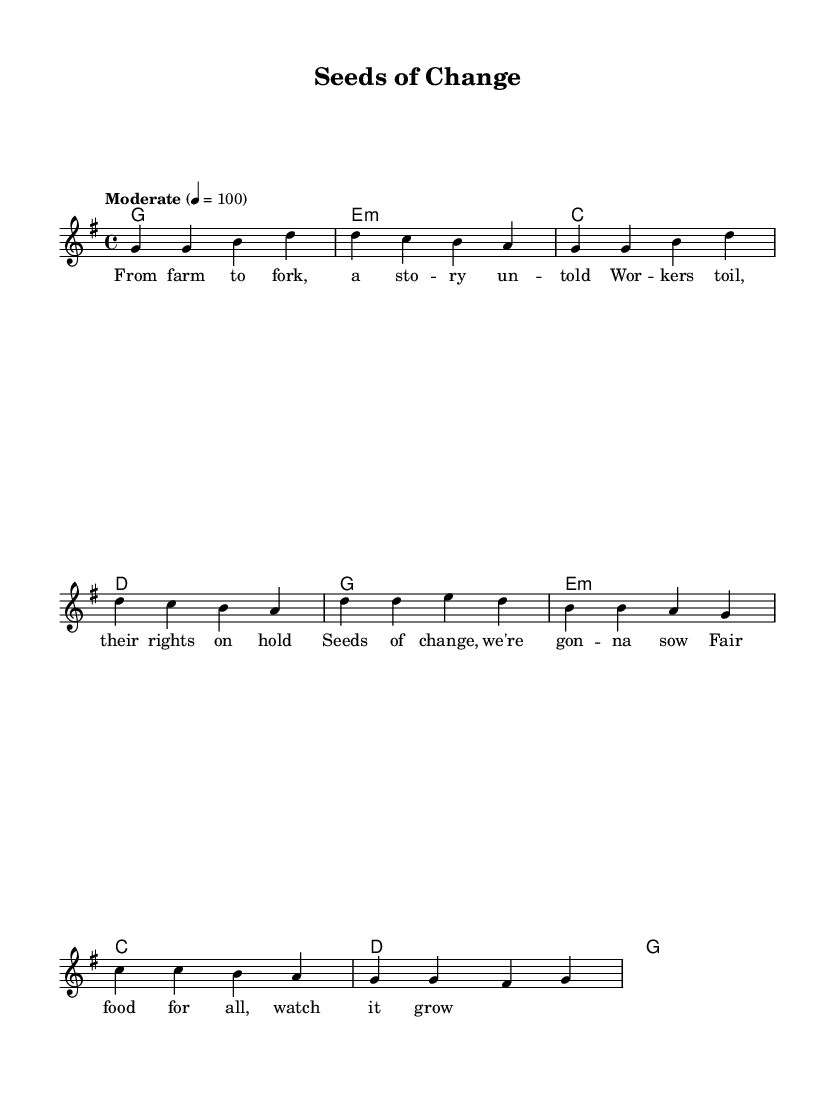What is the key signature of this music? The key signature is G major, which contains one sharp (F#). This is indicated at the beginning of the staff.
Answer: G major What is the time signature of this music? The time signature is 4/4, shown prominently after the clef sign. This means there are four beats in each measure, and the quarter note receives one beat.
Answer: 4/4 What is the tempo of the music? The tempo marking indicates a moderate speed of quarter note equals 100. This is found in the tempo directive near the beginning of the score.
Answer: Moderate 4 = 100 How many measures are in the verse? The verse contains four measures as shown in the melody line. You can count the vertical bar lines that separate the measures.
Answer: 4 Identify the chord that accompanies the chorus. The chorus is harmonized with the G major chord, which is the first chord noted in the chorus section of the harmonies. It is the main chord in the first measure of the chorus.
Answer: G What lyrical theme does the song address? The lyrics of the song focus on workers' rights and food justice, as indicated by phrases like "workers toil" and "fair food for all." This reflects the protest folk music theme of advocating for social issues.
Answer: Workers' rights and food justice What is the last note of the chorus? The last note of the chorus is G, which is the concluding note indicated in the melody line of the chorus section. It is found in the final melody measure.
Answer: G 